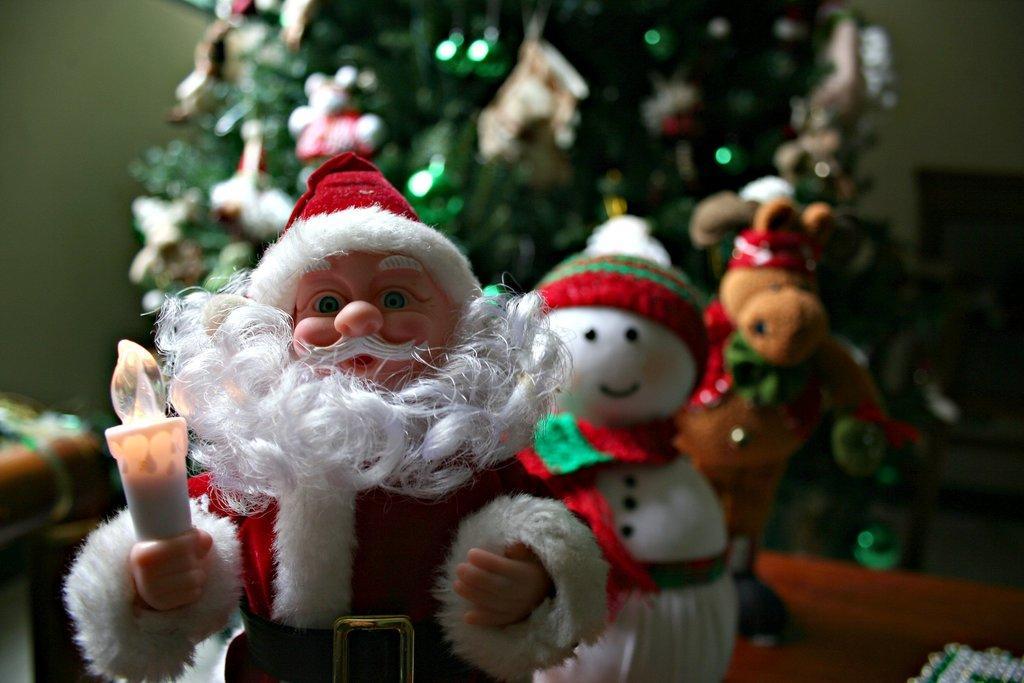Describe this image in one or two sentences. In this image there is santa claus,in the background there are two toys and a christmas tree. 